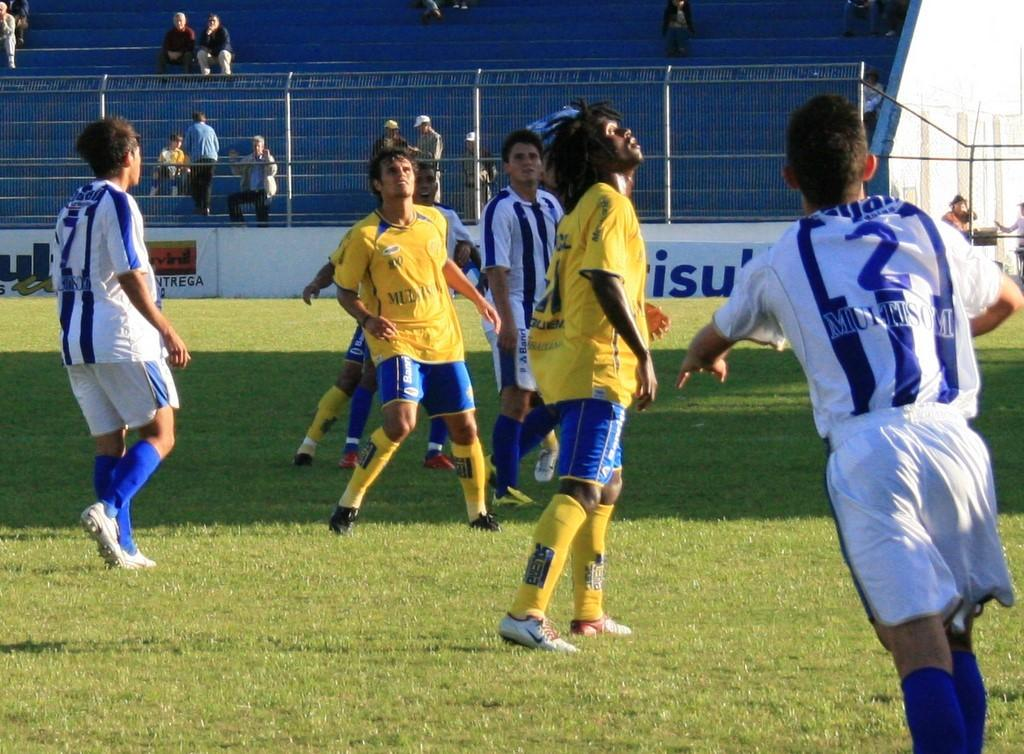<image>
Create a compact narrative representing the image presented. Several soccer players, including jersey number 2, compete on the field. 